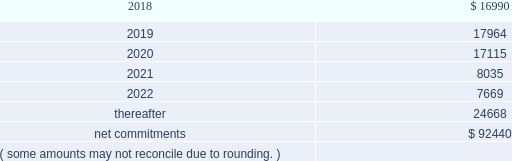On november 18 , 2014 , the company entered into a collateralized reinsurance agreement with kilimanjaro to provide the company with catastrophe reinsurance coverage .
This agreement is a multi-year reinsurance contract which covers specified earthquake events .
The agreement provides up to $ 500000 thousand of reinsurance coverage from earthquakes in the united states , puerto rico and canada .
On december 1 , 2015 the company entered into two collateralized reinsurance agreements with kilimanjaro re to provide the company with catastrophe reinsurance coverage .
These agreements are multi-year reinsurance contracts which cover named storm and earthquake events .
The first agreement provides up to $ 300000 thousand of reinsurance coverage from named storms and earthquakes in the united states , puerto rico and canada .
The second agreement provides up to $ 325000 thousand of reinsurance coverage from named storms and earthquakes in the united states , puerto rico and canada .
On april 13 , 2017 the company entered into six collateralized reinsurance agreements with kilimanjaro to provide the company with annual aggregate catastrophe reinsurance coverage .
The initial three agreements are four year reinsurance contracts which cover named storm and earthquake events .
These agreements provide up to $ 225000 thousand , $ 400000 thousand and $ 325000 thousand , respectively , of annual aggregate reinsurance coverage from named storms and earthquakes in the united states , puerto rico and canada .
The subsequent three agreements are five year reinsurance contracts which cover named storm and earthquake events .
These agreements provide up to $ 50000 thousand , $ 75000 thousand and $ 175000 thousand , respectively , of annual aggregate reinsurance coverage from named storms and earthquakes in the united states , puerto rico and canada .
Recoveries under these collateralized reinsurance agreements with kilimanjaro are primarily dependent on estimated industry level insured losses from covered events , as well as , the geographic location of the events .
The estimated industry level of insured losses is obtained from published estimates by an independent recognized authority on insured property losses .
As of december 31 , 2017 , none of the published insured loss estimates for the 2017 catastrophe events have exceeded the single event retentions under the terms of the agreements that would result in a recovery .
In addition , the aggregation of the to-date published insured loss estimates for the 2017 covered events have not exceeded the aggregated retentions for recovery .
However , if the published estimates for insured losses for the covered 2017 events increase , the aggregate losses may exceed the aggregate event retentions under the agreements , resulting in a recovery .
Kilimanjaro has financed the various property catastrophe reinsurance coverages by issuing catastrophe bonds to unrelated , external investors .
On april 24 , 2014 , kilimanjaro issued $ 450000 thousand of notes ( 201cseries 2014-1 notes 201d ) .
On november 18 , 2014 , kilimanjaro issued $ 500000 thousand of notes ( 201cseries 2014-2 notes 201d ) .
On december 1 , 2015 , kilimanjaro issued $ 625000 thousand of notes ( 201cseries 2015-1 notes ) .
On april 13 , 2017 , kilimanjaro issued $ 950000 thousand of notes ( 201cseries 2017-1 notes ) and $ 300000 thousand of notes ( 201cseries 2017-2 notes ) .
The proceeds from the issuance of the notes listed above are held in reinsurance trust throughout the duration of the applicable reinsurance agreements and invested solely in us government money market funds with a rating of at least 201caaam 201d by standard & poor 2019s .
Operating lease agreements the future minimum rental commitments , exclusive of cost escalation clauses , at december 31 , 2017 , for all of the company 2019s operating leases with remaining non-cancelable terms in excess of one year are as follows : ( dollars in thousands ) .

What was the total value of notes issued by kilimanjaro in 2014 in thousands? 
Computations: (500000 + 450000)
Answer: 950000.0. 